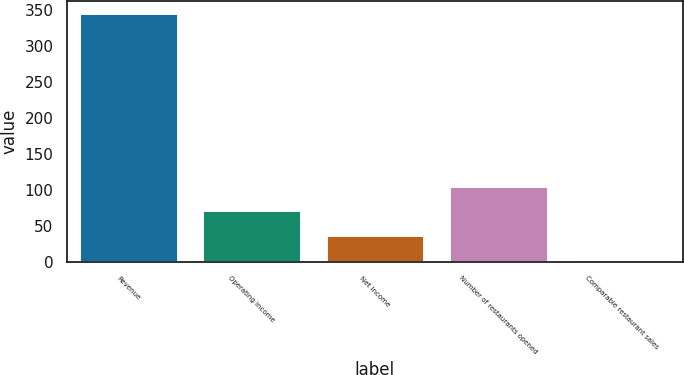<chart> <loc_0><loc_0><loc_500><loc_500><bar_chart><fcel>Revenue<fcel>Operating income<fcel>Net income<fcel>Number of restaurants opened<fcel>Comparable restaurant sales<nl><fcel>345.3<fcel>71.86<fcel>37.68<fcel>106.04<fcel>3.5<nl></chart> 